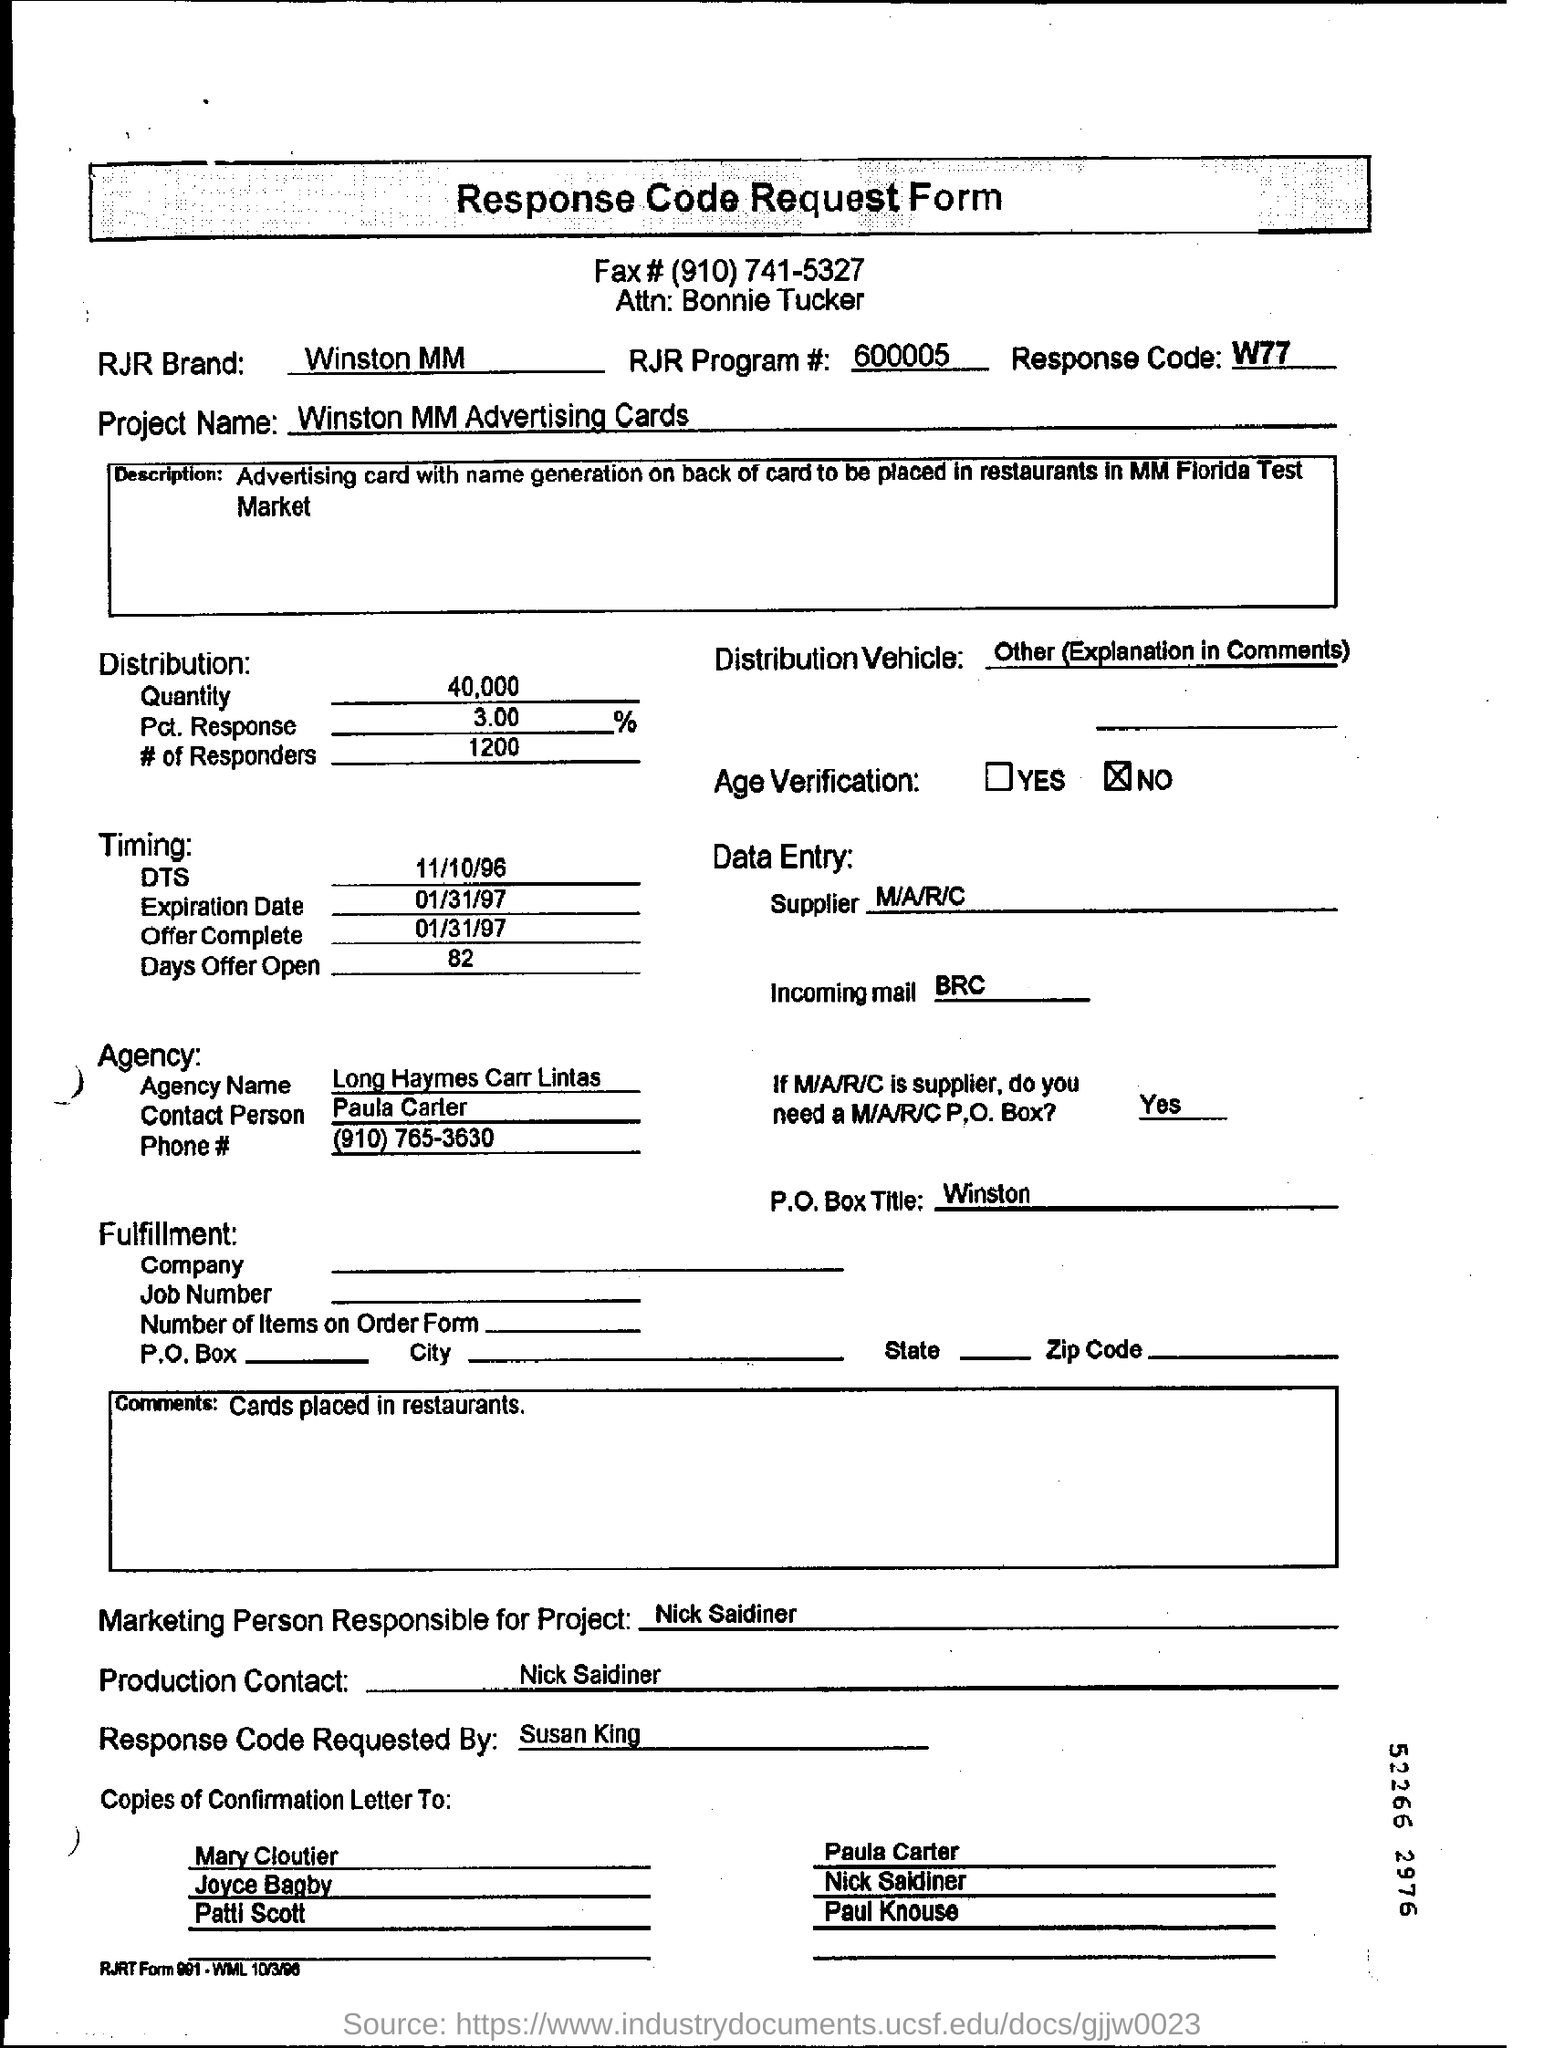Point out several critical features in this image. The person in charge of production is Nick Saidiner. This is the name of the project: Winston MM Advertising Cards. What is the date of expiration? This is a date of January 31, 1997. The response code is W77... 